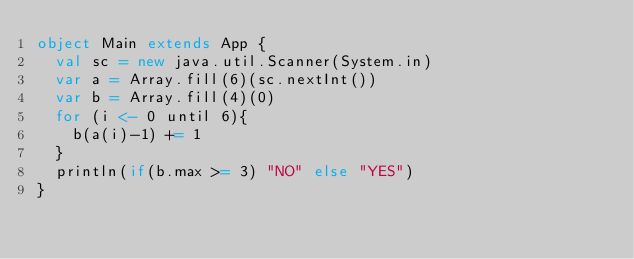Convert code to text. <code><loc_0><loc_0><loc_500><loc_500><_Scala_>object Main extends App {
  val sc = new java.util.Scanner(System.in)
  var a = Array.fill(6)(sc.nextInt())
  var b = Array.fill(4)(0)
  for (i <- 0 until 6){
    b(a(i)-1) += 1
  }
  println(if(b.max >= 3) "NO" else "YES")
}
</code> 